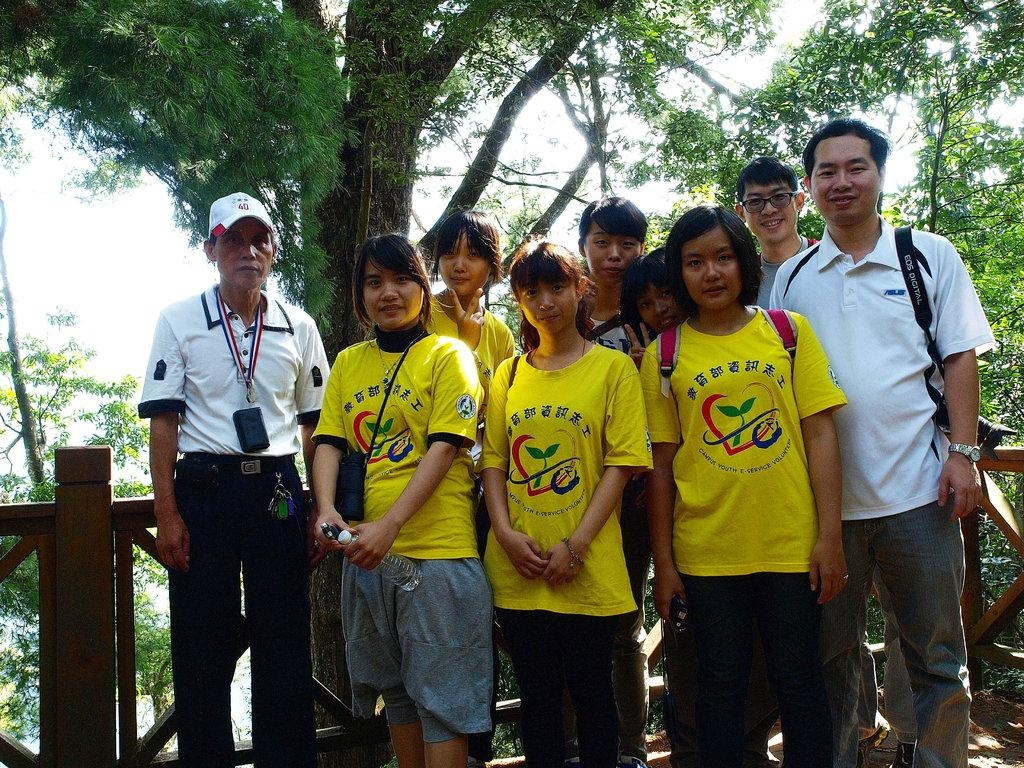What can be observed about the attire of the persons in the image? There are persons in different color dresses in the image. What is the facial expression of some of the persons in the image? Some of the persons are smiling. Where are the persons standing in the image? The persons are standing near wooden fencing. What can be seen in the background of the image? There are trees and the sky visible in the background of the image. What type of soup is being served in the image? There is no soup present in the image. Can you hear the song that the persons are singing in the image? There is no indication of any song or singing in the image. 